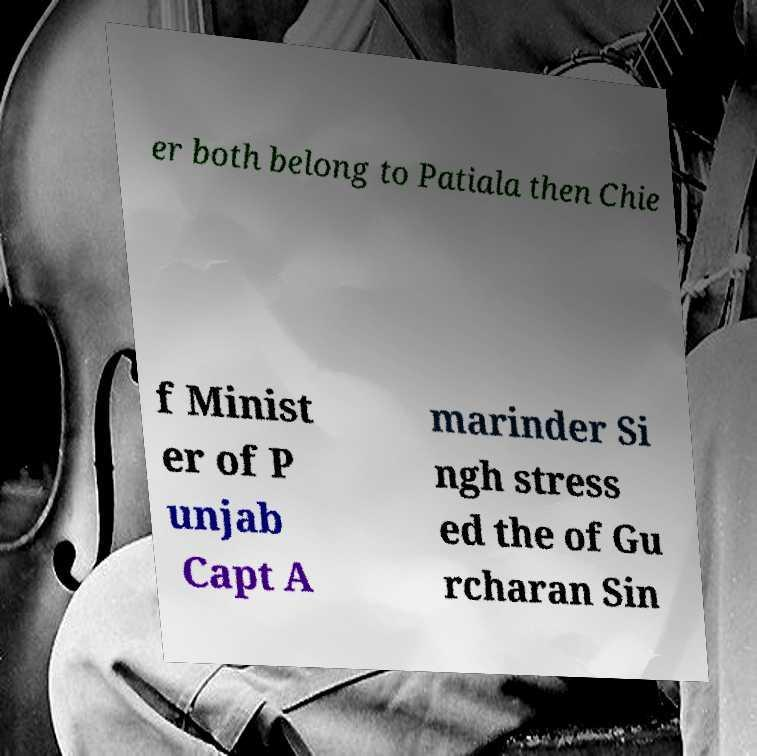Please identify and transcribe the text found in this image. er both belong to Patiala then Chie f Minist er of P unjab Capt A marinder Si ngh stress ed the of Gu rcharan Sin 